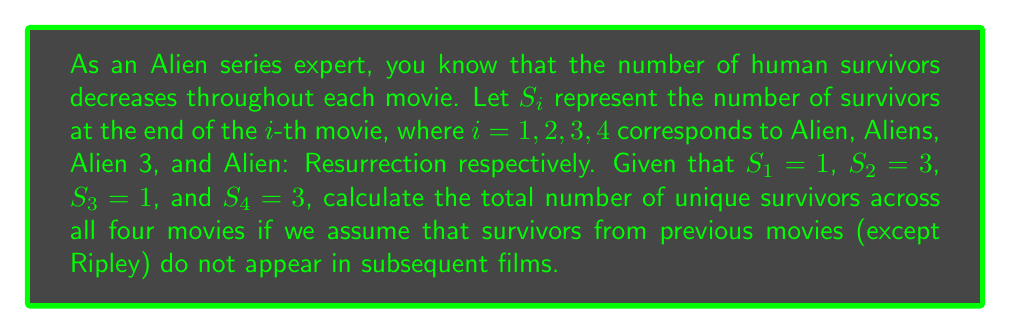Can you answer this question? To solve this problem, we need to sum up the number of survivors from each movie, but we must be careful not to double-count Ripley, who survives multiple films. Let's break it down step by step:

1) Alien ($S_1$): 1 survivor (Ripley)
2) Aliens ($S_2$): 3 survivors (Ripley, Newt, and Hicks)
3) Alien 3 ($S_3$): 1 survivor (Ripley, who dies at the end but is counted here)
4) Alien: Resurrection ($S_4$): 3 survivors (Ripley clone, Call, and Johner)

Now, let's calculate the total unique survivors:

$$\text{Total} = S_1 + (S_2 - 1) + (S_3 - 1) + S_4$$

We subtract 1 from $S_2$ and $S_3$ because Ripley is already counted in $S_1$. We don't subtract from $S_4$ because the Ripley in this movie is a clone and considered a new character.

Substituting the values:

$$\text{Total} = 1 + (3 - 1) + (1 - 1) + 3$$
$$\text{Total} = 1 + 2 + 0 + 3$$
$$\text{Total} = 6$$

Therefore, there are 6 unique human survivors across all four Alien movies.
Answer: 6 unique survivors 